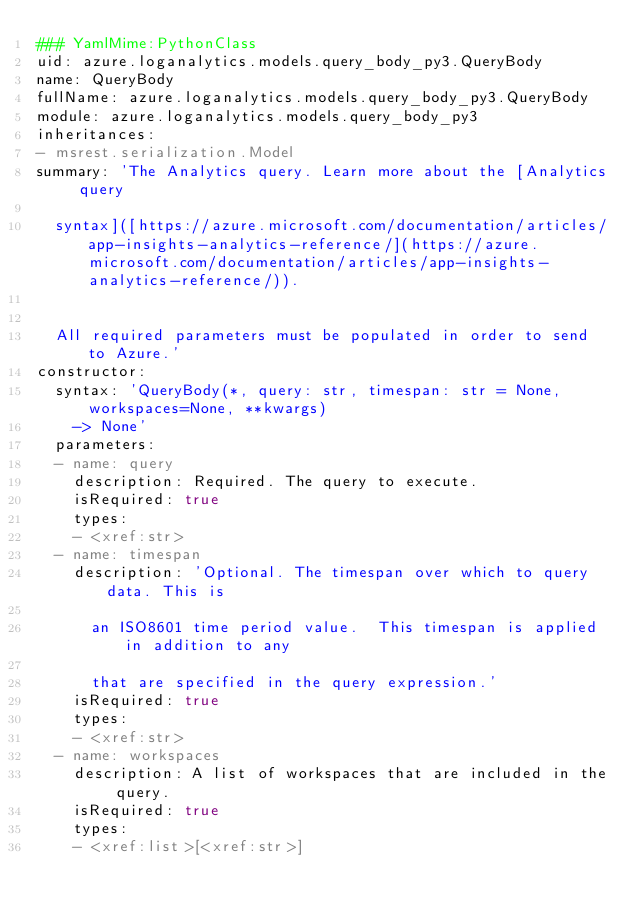<code> <loc_0><loc_0><loc_500><loc_500><_YAML_>### YamlMime:PythonClass
uid: azure.loganalytics.models.query_body_py3.QueryBody
name: QueryBody
fullName: azure.loganalytics.models.query_body_py3.QueryBody
module: azure.loganalytics.models.query_body_py3
inheritances:
- msrest.serialization.Model
summary: 'The Analytics query. Learn more about the [Analytics query

  syntax]([https://azure.microsoft.com/documentation/articles/app-insights-analytics-reference/](https://azure.microsoft.com/documentation/articles/app-insights-analytics-reference/)).


  All required parameters must be populated in order to send to Azure.'
constructor:
  syntax: 'QueryBody(*, query: str, timespan: str = None, workspaces=None, **kwargs)
    -> None'
  parameters:
  - name: query
    description: Required. The query to execute.
    isRequired: true
    types:
    - <xref:str>
  - name: timespan
    description: 'Optional. The timespan over which to query data. This is

      an ISO8601 time period value.  This timespan is applied in addition to any

      that are specified in the query expression.'
    isRequired: true
    types:
    - <xref:str>
  - name: workspaces
    description: A list of workspaces that are included in the query.
    isRequired: true
    types:
    - <xref:list>[<xref:str>]
</code> 